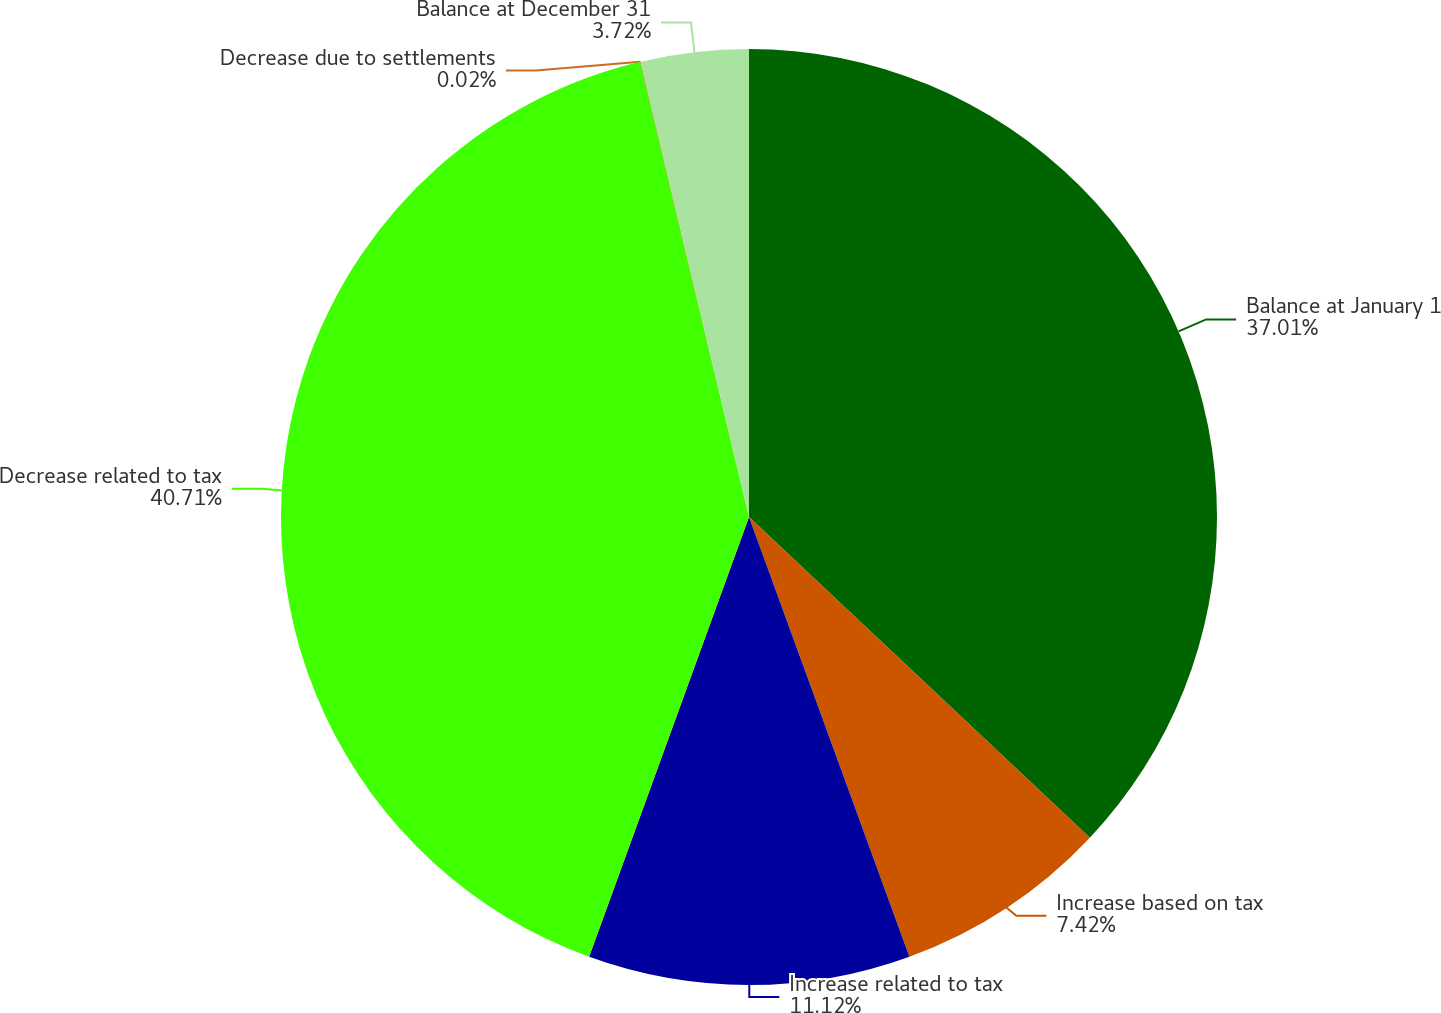Convert chart to OTSL. <chart><loc_0><loc_0><loc_500><loc_500><pie_chart><fcel>Balance at January 1<fcel>Increase based on tax<fcel>Increase related to tax<fcel>Decrease related to tax<fcel>Decrease due to settlements<fcel>Balance at December 31<nl><fcel>37.02%<fcel>7.42%<fcel>11.12%<fcel>40.72%<fcel>0.02%<fcel>3.72%<nl></chart> 